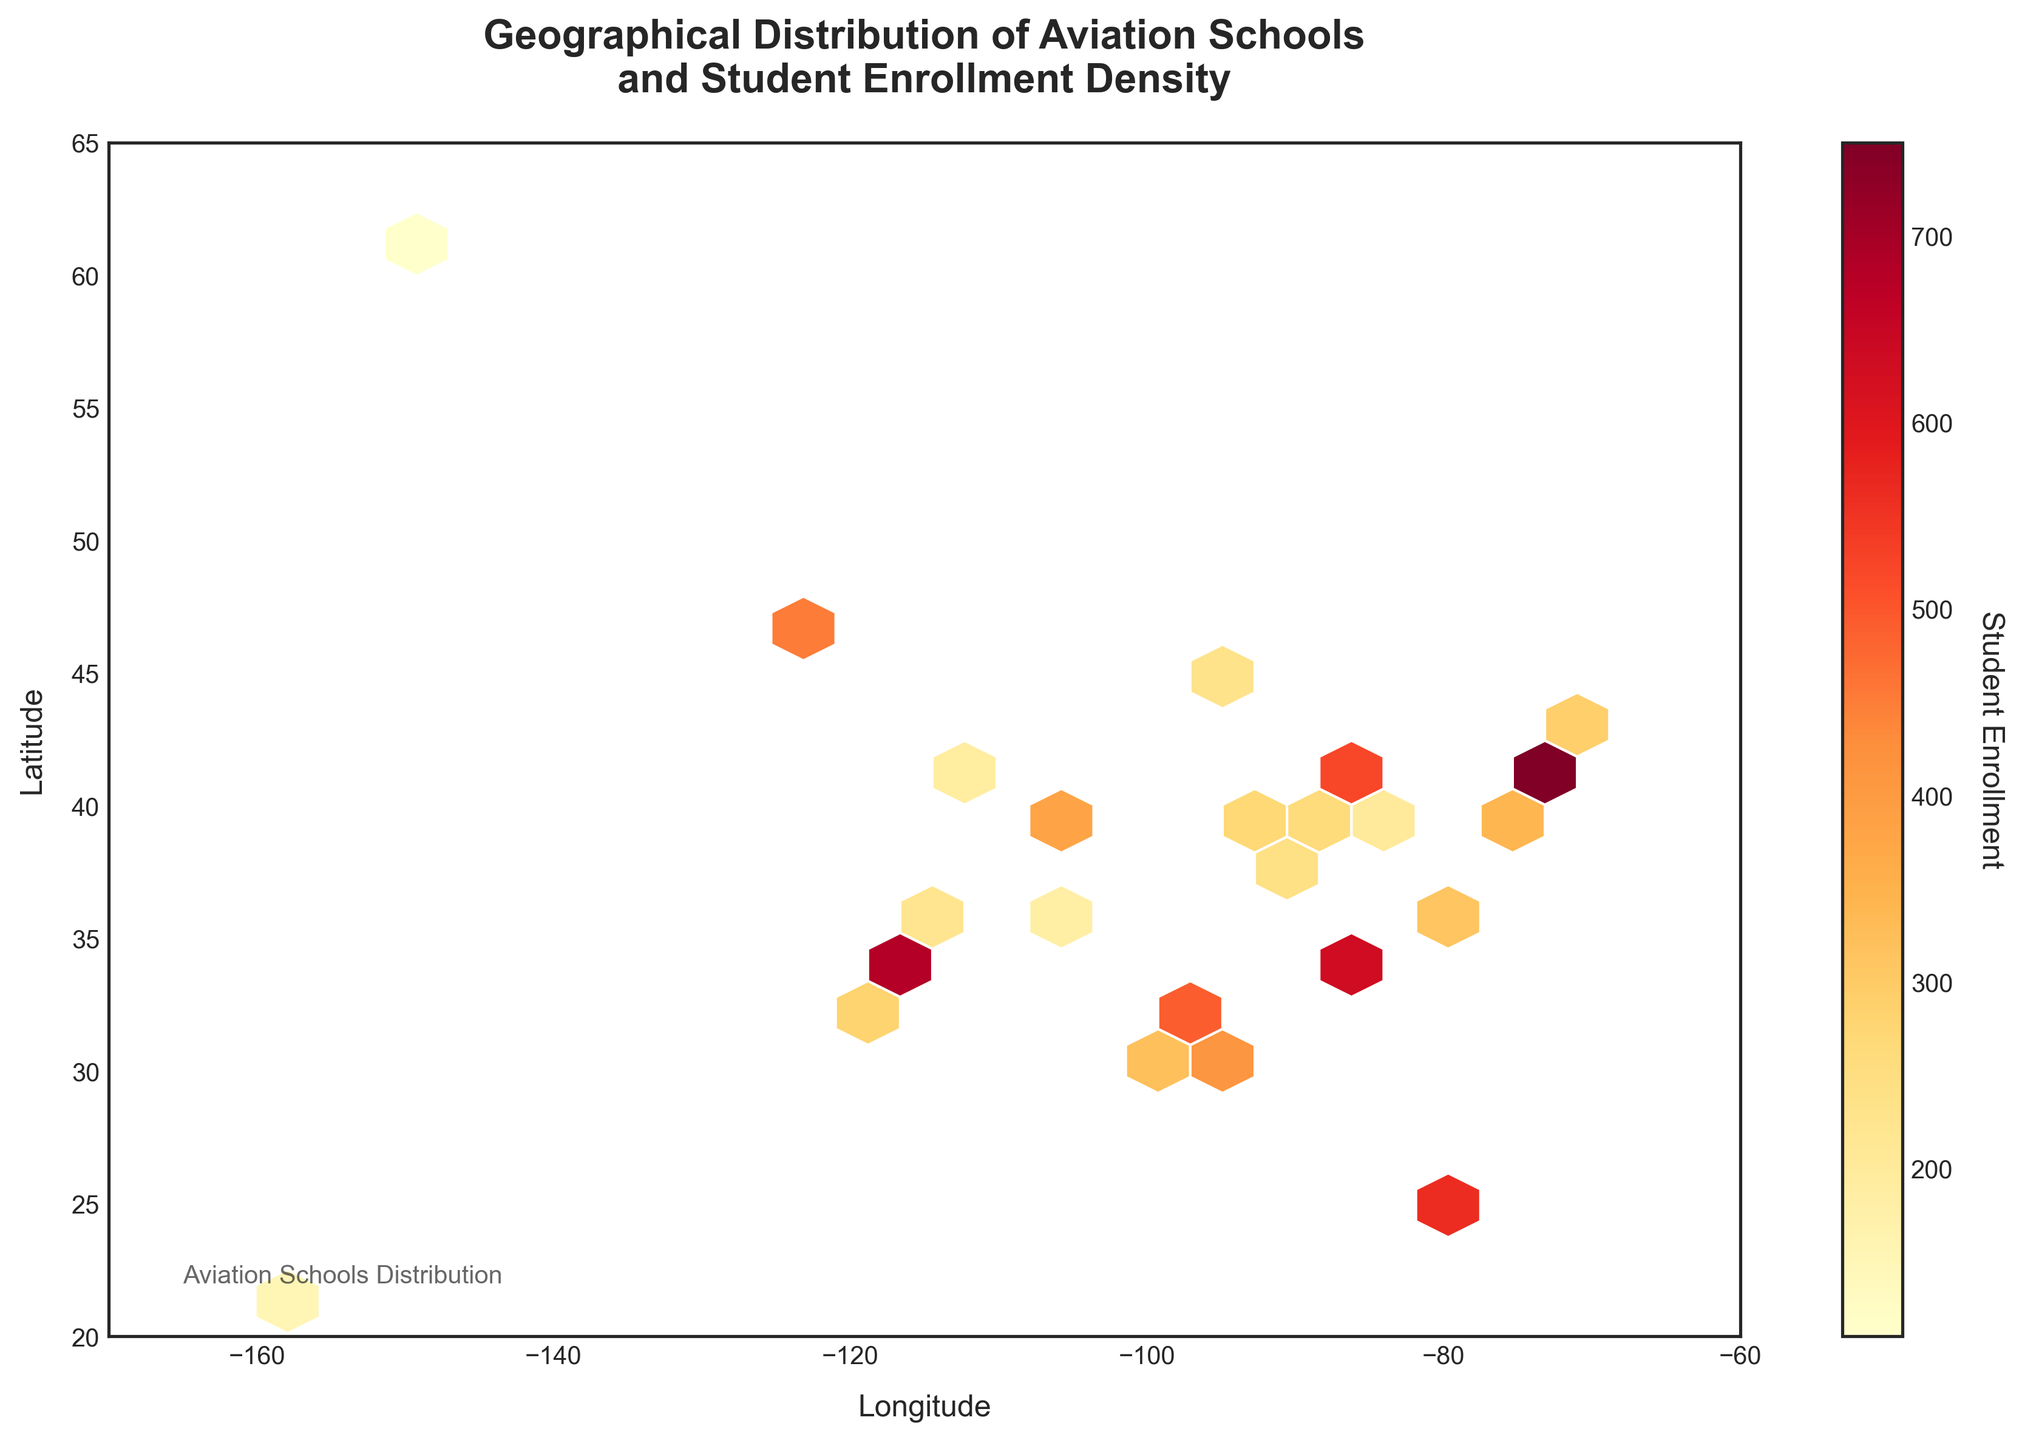What is the title of the plot? The title of the plot is located at the top center.
Answer: Geographical Distribution of Aviation Schools and Student Enrollment Density What does the color represent in this plot? The color in the plot represents the density of student enrollments, with a color gradient indicating different densities.
Answer: Student Enrollment What are the axes labels? The axes labels are found next to the respective axes.
Answer: Longitude and Latitude Which region seems to have the highest student enrollment density? The region with the highest student enrollment density can be identified by the brightest color in the plot.
Answer: Around 40°N, -74°W (New York area) Are there more aviation schools clustered on the East Coast or the West Coast? By comparing the density of hexagons with values on the East Coast and the West Coast, we can determine the clustering.
Answer: East Coast What is the average enrollment density in the central US? To find this, we sum the student enrollments for the central region and divide by the number of hexagons in that region.
Answer: Requires computation; inspect the plot How many data points are represented on this plot? Each hexagon represents multiple data points; by counting hexagons, we estimate the data points.
Answer: Multiple; exact count requires inspection Which state is likely to have the lowest student enrollment density? The lowest density is indicated by hexagons with the faintest color or empty regions.
Answer: States in the Mountain West (e.g., Utah, Nevada) What is the color gradient used in the plot? The color gradient helps to visually differentiate different densities of student enrollments.
Answer: Yellows to Reds (Yellow-Orange-Red) How is the student enrollment density distributed in California? By examining the density of hexagons in the California state region (around -120°W to -114°W, 32°N to 38°N), we can understand its distribution.
Answer: Moderate to high density in the south 